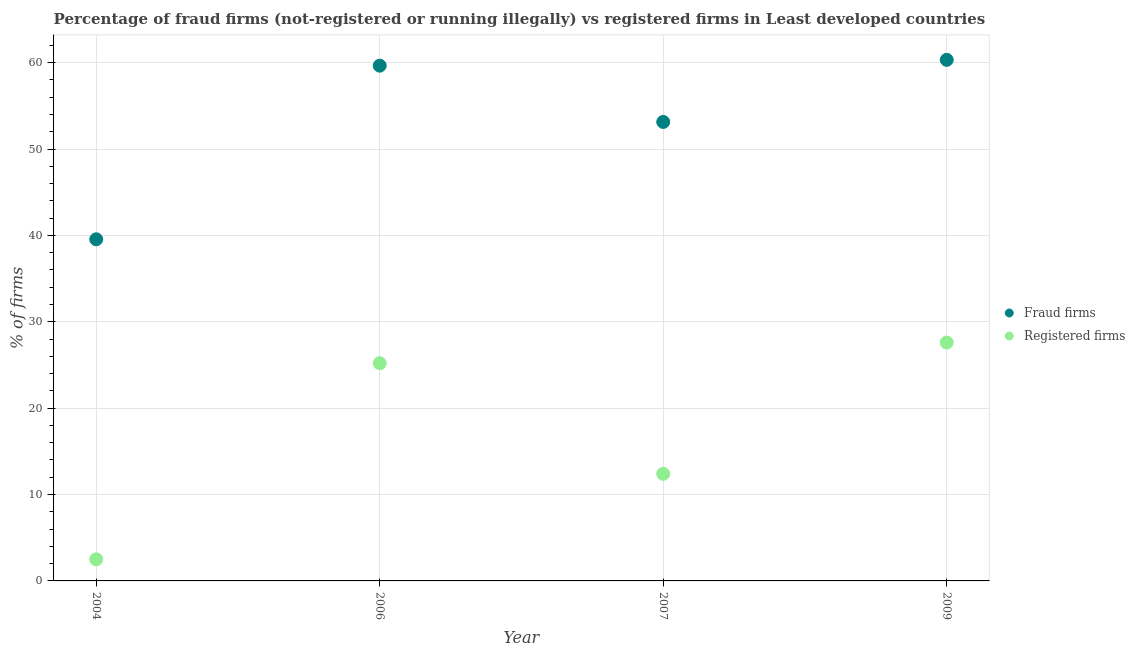How many different coloured dotlines are there?
Offer a terse response. 2. Is the number of dotlines equal to the number of legend labels?
Your response must be concise. Yes. What is the percentage of registered firms in 2009?
Your answer should be compact. 27.6. Across all years, what is the maximum percentage of registered firms?
Keep it short and to the point. 27.6. Across all years, what is the minimum percentage of fraud firms?
Provide a succinct answer. 39.55. What is the total percentage of registered firms in the graph?
Provide a succinct answer. 67.71. What is the difference between the percentage of fraud firms in 2007 and that in 2009?
Ensure brevity in your answer.  -7.19. What is the difference between the percentage of fraud firms in 2006 and the percentage of registered firms in 2009?
Offer a very short reply. 32.05. What is the average percentage of fraud firms per year?
Offer a very short reply. 53.17. In the year 2009, what is the difference between the percentage of fraud firms and percentage of registered firms?
Offer a terse response. 32.73. What is the ratio of the percentage of registered firms in 2007 to that in 2009?
Offer a terse response. 0.45. Is the percentage of registered firms in 2007 less than that in 2009?
Your answer should be very brief. Yes. What is the difference between the highest and the second highest percentage of fraud firms?
Your response must be concise. 0.67. What is the difference between the highest and the lowest percentage of fraud firms?
Your answer should be very brief. 20.78. Does the percentage of fraud firms monotonically increase over the years?
Your response must be concise. No. Is the percentage of registered firms strictly greater than the percentage of fraud firms over the years?
Give a very brief answer. No. How many years are there in the graph?
Offer a terse response. 4. What is the difference between two consecutive major ticks on the Y-axis?
Your answer should be compact. 10. Are the values on the major ticks of Y-axis written in scientific E-notation?
Your answer should be very brief. No. Does the graph contain grids?
Offer a very short reply. Yes. How many legend labels are there?
Your answer should be compact. 2. How are the legend labels stacked?
Provide a succinct answer. Vertical. What is the title of the graph?
Offer a terse response. Percentage of fraud firms (not-registered or running illegally) vs registered firms in Least developed countries. What is the label or title of the Y-axis?
Offer a terse response. % of firms. What is the % of firms of Fraud firms in 2004?
Ensure brevity in your answer.  39.55. What is the % of firms of Fraud firms in 2006?
Ensure brevity in your answer.  59.65. What is the % of firms of Registered firms in 2006?
Offer a terse response. 25.21. What is the % of firms of Fraud firms in 2007?
Offer a terse response. 53.14. What is the % of firms in Registered firms in 2007?
Ensure brevity in your answer.  12.4. What is the % of firms of Fraud firms in 2009?
Ensure brevity in your answer.  60.33. What is the % of firms of Registered firms in 2009?
Your response must be concise. 27.6. Across all years, what is the maximum % of firms of Fraud firms?
Provide a short and direct response. 60.33. Across all years, what is the maximum % of firms of Registered firms?
Your answer should be very brief. 27.6. Across all years, what is the minimum % of firms of Fraud firms?
Offer a very short reply. 39.55. Across all years, what is the minimum % of firms in Registered firms?
Provide a succinct answer. 2.5. What is the total % of firms in Fraud firms in the graph?
Your answer should be very brief. 212.66. What is the total % of firms in Registered firms in the graph?
Your answer should be very brief. 67.71. What is the difference between the % of firms in Fraud firms in 2004 and that in 2006?
Offer a very short reply. -20.1. What is the difference between the % of firms of Registered firms in 2004 and that in 2006?
Your answer should be very brief. -22.71. What is the difference between the % of firms in Fraud firms in 2004 and that in 2007?
Your answer should be very brief. -13.59. What is the difference between the % of firms of Fraud firms in 2004 and that in 2009?
Your answer should be very brief. -20.77. What is the difference between the % of firms in Registered firms in 2004 and that in 2009?
Offer a terse response. -25.1. What is the difference between the % of firms of Fraud firms in 2006 and that in 2007?
Make the answer very short. 6.51. What is the difference between the % of firms in Registered firms in 2006 and that in 2007?
Offer a very short reply. 12.81. What is the difference between the % of firms of Fraud firms in 2006 and that in 2009?
Ensure brevity in your answer.  -0.67. What is the difference between the % of firms in Registered firms in 2006 and that in 2009?
Your answer should be compact. -2.39. What is the difference between the % of firms in Fraud firms in 2007 and that in 2009?
Keep it short and to the point. -7.19. What is the difference between the % of firms of Registered firms in 2007 and that in 2009?
Offer a very short reply. -15.2. What is the difference between the % of firms of Fraud firms in 2004 and the % of firms of Registered firms in 2006?
Your answer should be compact. 14.34. What is the difference between the % of firms in Fraud firms in 2004 and the % of firms in Registered firms in 2007?
Make the answer very short. 27.15. What is the difference between the % of firms in Fraud firms in 2004 and the % of firms in Registered firms in 2009?
Your answer should be compact. 11.95. What is the difference between the % of firms in Fraud firms in 2006 and the % of firms in Registered firms in 2007?
Offer a terse response. 47.25. What is the difference between the % of firms in Fraud firms in 2006 and the % of firms in Registered firms in 2009?
Provide a short and direct response. 32.05. What is the difference between the % of firms of Fraud firms in 2007 and the % of firms of Registered firms in 2009?
Give a very brief answer. 25.54. What is the average % of firms of Fraud firms per year?
Your answer should be compact. 53.17. What is the average % of firms of Registered firms per year?
Offer a terse response. 16.93. In the year 2004, what is the difference between the % of firms in Fraud firms and % of firms in Registered firms?
Keep it short and to the point. 37.05. In the year 2006, what is the difference between the % of firms in Fraud firms and % of firms in Registered firms?
Your answer should be compact. 34.45. In the year 2007, what is the difference between the % of firms of Fraud firms and % of firms of Registered firms?
Offer a very short reply. 40.74. In the year 2009, what is the difference between the % of firms of Fraud firms and % of firms of Registered firms?
Make the answer very short. 32.73. What is the ratio of the % of firms of Fraud firms in 2004 to that in 2006?
Give a very brief answer. 0.66. What is the ratio of the % of firms in Registered firms in 2004 to that in 2006?
Provide a short and direct response. 0.1. What is the ratio of the % of firms of Fraud firms in 2004 to that in 2007?
Offer a very short reply. 0.74. What is the ratio of the % of firms of Registered firms in 2004 to that in 2007?
Ensure brevity in your answer.  0.2. What is the ratio of the % of firms of Fraud firms in 2004 to that in 2009?
Offer a terse response. 0.66. What is the ratio of the % of firms of Registered firms in 2004 to that in 2009?
Give a very brief answer. 0.09. What is the ratio of the % of firms of Fraud firms in 2006 to that in 2007?
Provide a succinct answer. 1.12. What is the ratio of the % of firms of Registered firms in 2006 to that in 2007?
Your answer should be compact. 2.03. What is the ratio of the % of firms of Registered firms in 2006 to that in 2009?
Keep it short and to the point. 0.91. What is the ratio of the % of firms of Fraud firms in 2007 to that in 2009?
Keep it short and to the point. 0.88. What is the ratio of the % of firms in Registered firms in 2007 to that in 2009?
Offer a very short reply. 0.45. What is the difference between the highest and the second highest % of firms of Fraud firms?
Offer a terse response. 0.67. What is the difference between the highest and the second highest % of firms in Registered firms?
Your answer should be compact. 2.39. What is the difference between the highest and the lowest % of firms of Fraud firms?
Provide a short and direct response. 20.77. What is the difference between the highest and the lowest % of firms in Registered firms?
Ensure brevity in your answer.  25.1. 